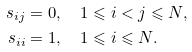Convert formula to latex. <formula><loc_0><loc_0><loc_500><loc_500>s _ { i j } & = 0 , \quad 1 \leqslant i < j \leqslant N , \\ s _ { i i } & = 1 , \quad 1 \leqslant i \leqslant N .</formula> 